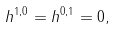<formula> <loc_0><loc_0><loc_500><loc_500>h ^ { 1 , 0 } = h ^ { 0 , 1 } = 0 ,</formula> 